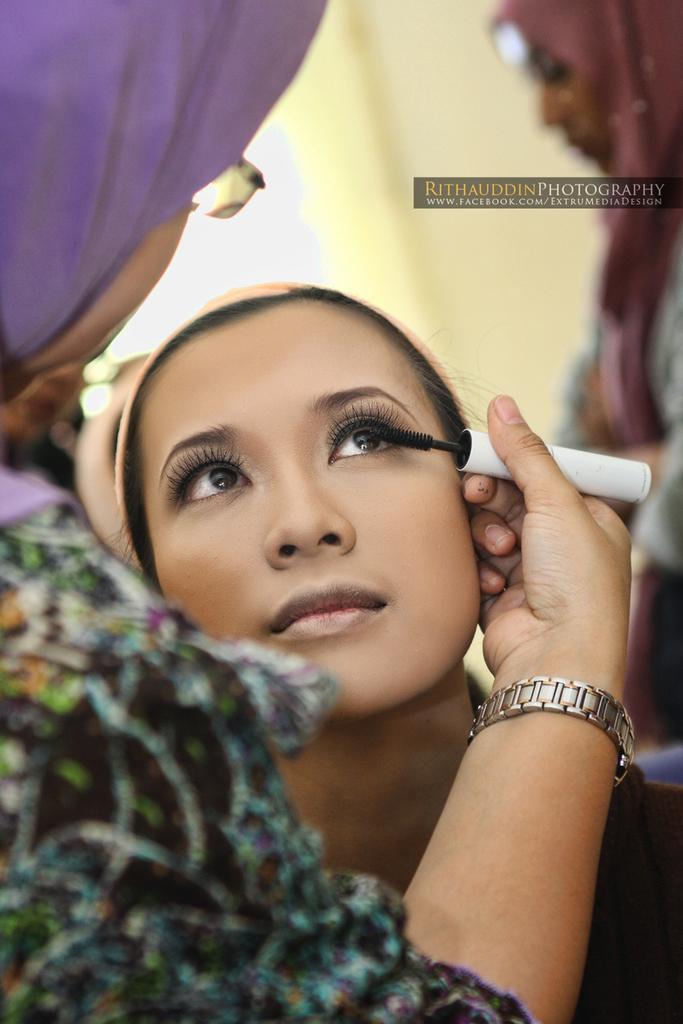In one or two sentences, can you explain what this image depicts? In this image a lady in the left is applying mascara to the lady sitting in front of her. On the top right there is another lady. In the background there is wall. 